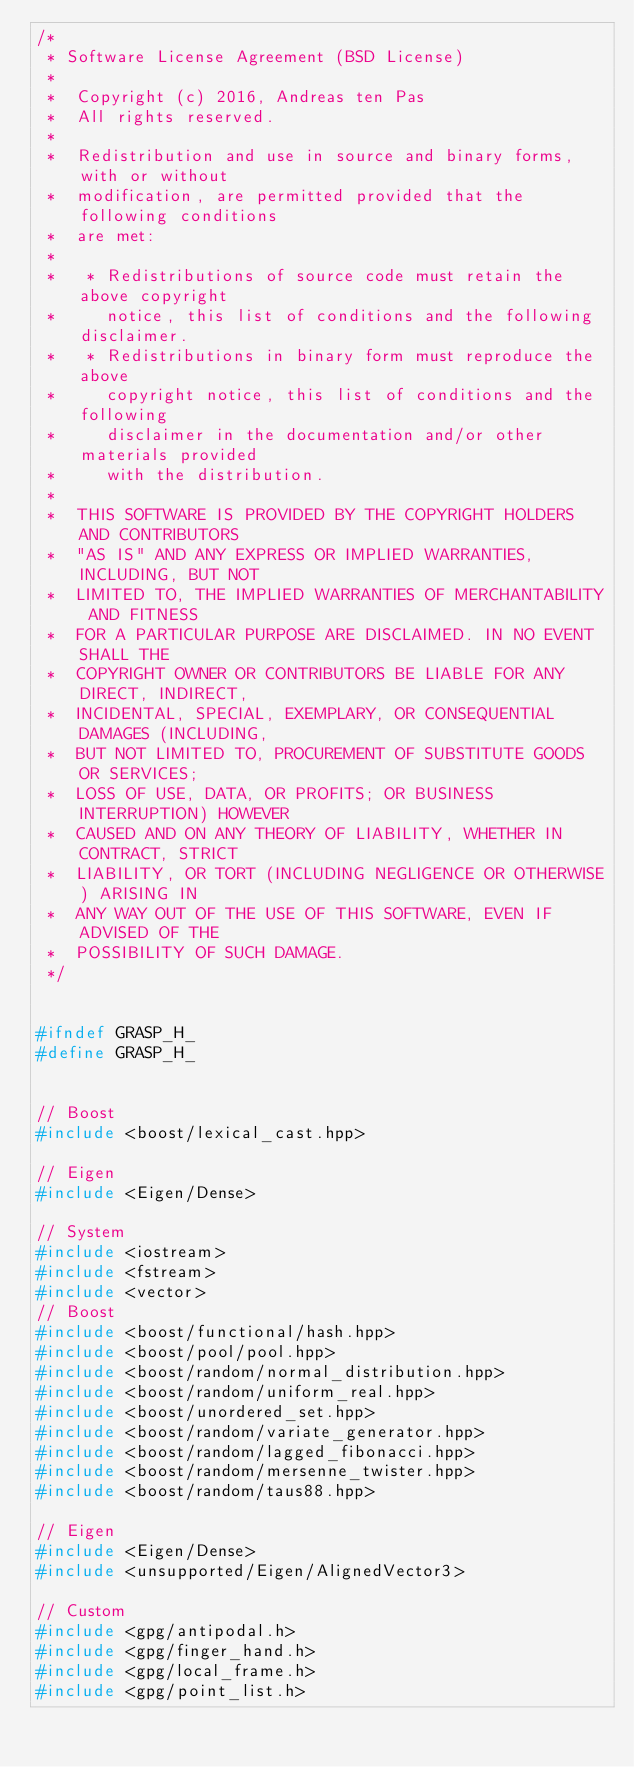Convert code to text. <code><loc_0><loc_0><loc_500><loc_500><_C_>/*
 * Software License Agreement (BSD License)
 *
 *  Copyright (c) 2016, Andreas ten Pas
 *  All rights reserved.
 *
 *  Redistribution and use in source and binary forms, with or without
 *  modification, are permitted provided that the following conditions
 *  are met:
 *
 *   * Redistributions of source code must retain the above copyright
 *     notice, this list of conditions and the following disclaimer.
 *   * Redistributions in binary form must reproduce the above
 *     copyright notice, this list of conditions and the following
 *     disclaimer in the documentation and/or other materials provided
 *     with the distribution.
 *
 *  THIS SOFTWARE IS PROVIDED BY THE COPYRIGHT HOLDERS AND CONTRIBUTORS
 *  "AS IS" AND ANY EXPRESS OR IMPLIED WARRANTIES, INCLUDING, BUT NOT
 *  LIMITED TO, THE IMPLIED WARRANTIES OF MERCHANTABILITY AND FITNESS
 *  FOR A PARTICULAR PURPOSE ARE DISCLAIMED. IN NO EVENT SHALL THE
 *  COPYRIGHT OWNER OR CONTRIBUTORS BE LIABLE FOR ANY DIRECT, INDIRECT,
 *  INCIDENTAL, SPECIAL, EXEMPLARY, OR CONSEQUENTIAL DAMAGES (INCLUDING,
 *  BUT NOT LIMITED TO, PROCUREMENT OF SUBSTITUTE GOODS OR SERVICES;
 *  LOSS OF USE, DATA, OR PROFITS; OR BUSINESS INTERRUPTION) HOWEVER
 *  CAUSED AND ON ANY THEORY OF LIABILITY, WHETHER IN CONTRACT, STRICT
 *  LIABILITY, OR TORT (INCLUDING NEGLIGENCE OR OTHERWISE) ARISING IN
 *  ANY WAY OUT OF THE USE OF THIS SOFTWARE, EVEN IF ADVISED OF THE
 *  POSSIBILITY OF SUCH DAMAGE.
 */


#ifndef GRASP_H_
#define GRASP_H_


// Boost
#include <boost/lexical_cast.hpp>

// Eigen
#include <Eigen/Dense>

// System
#include <iostream>
#include <fstream>
#include <vector>
// Boost
#include <boost/functional/hash.hpp>
#include <boost/pool/pool.hpp>
#include <boost/random/normal_distribution.hpp>
#include <boost/random/uniform_real.hpp>
#include <boost/unordered_set.hpp>
#include <boost/random/variate_generator.hpp>
#include <boost/random/lagged_fibonacci.hpp>
#include <boost/random/mersenne_twister.hpp>
#include <boost/random/taus88.hpp>

// Eigen
#include <Eigen/Dense>
#include <unsupported/Eigen/AlignedVector3>

// Custom
#include <gpg/antipodal.h>
#include <gpg/finger_hand.h>
#include <gpg/local_frame.h>
#include <gpg/point_list.h>

</code> 